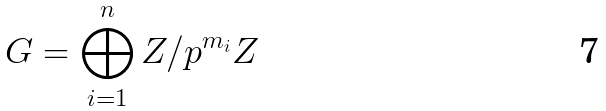<formula> <loc_0><loc_0><loc_500><loc_500>G = \bigoplus _ { i = 1 } ^ { n } { Z } / { p ^ { m _ { i } } Z }</formula> 